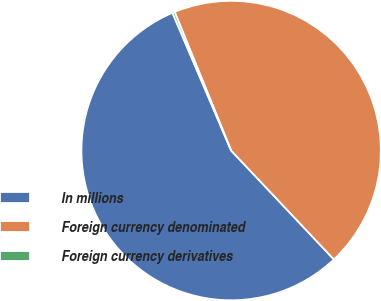<chart> <loc_0><loc_0><loc_500><loc_500><pie_chart><fcel>In millions<fcel>Foreign currency denominated<fcel>Foreign currency derivatives<nl><fcel>55.63%<fcel>44.12%<fcel>0.25%<nl></chart> 